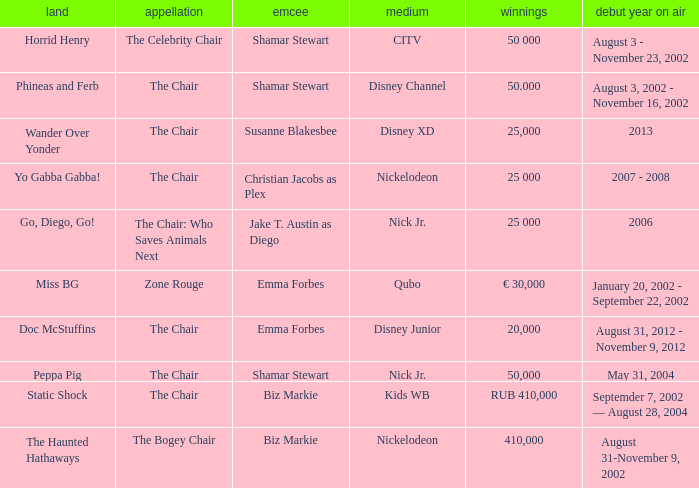What was the host of Horrid Henry? Shamar Stewart. 